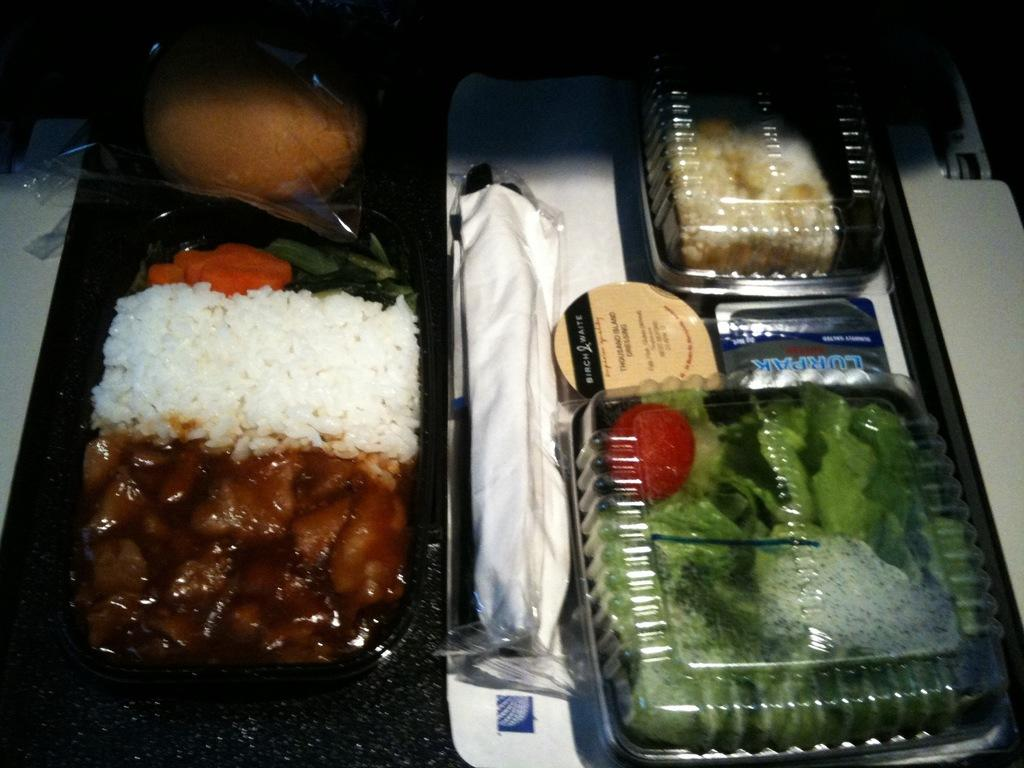<image>
Summarize the visual content of the image. a meal with a salad and thousand island dressing are ready to eat 